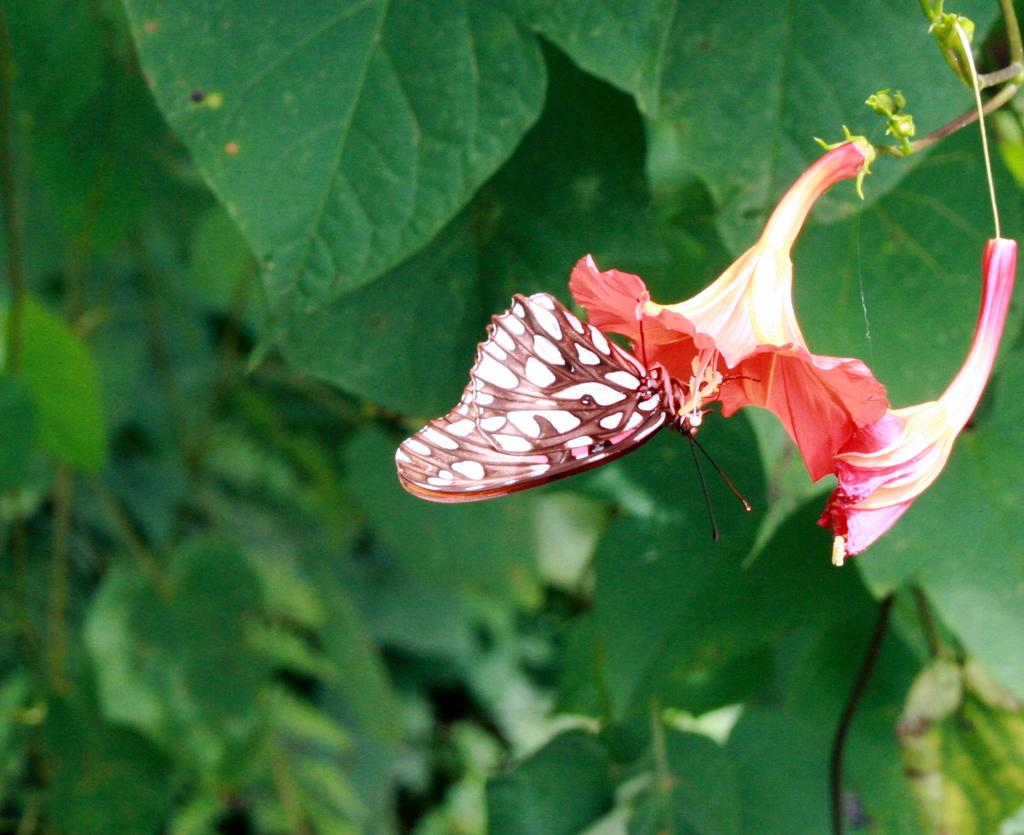What is the main subject of the image? The main subject of the image is a butterfly on a flower. What can be seen in the background of the image? There are leaves visible in the background of the image. What type of news is the butterfly reading on the flower? There is no news present in the image, as it features a butterfly on a flower and leaves in the background. 